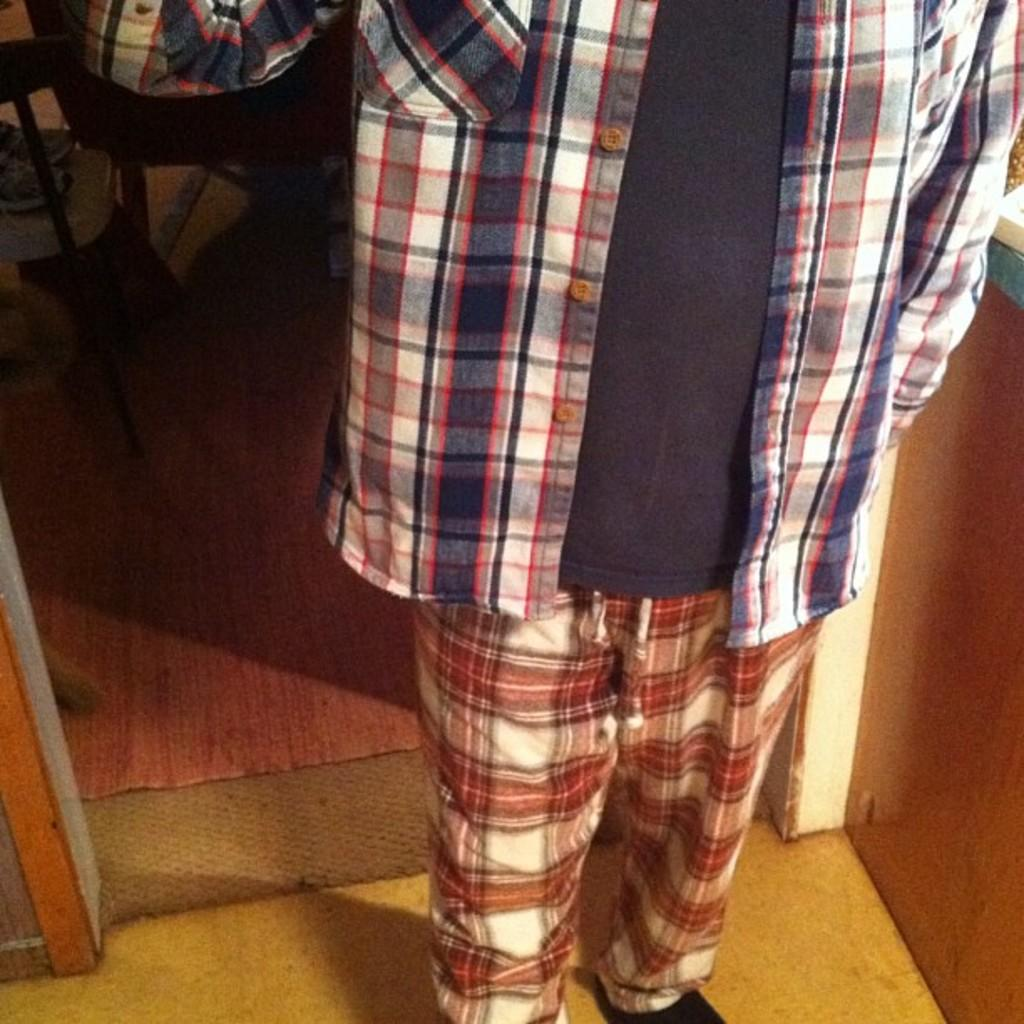What is the main subject of the image? The main subject of the image is an incomplete picture of a person. Where is the goat located in the image? There is no goat present in the image; it only contains an incomplete picture of a person. 